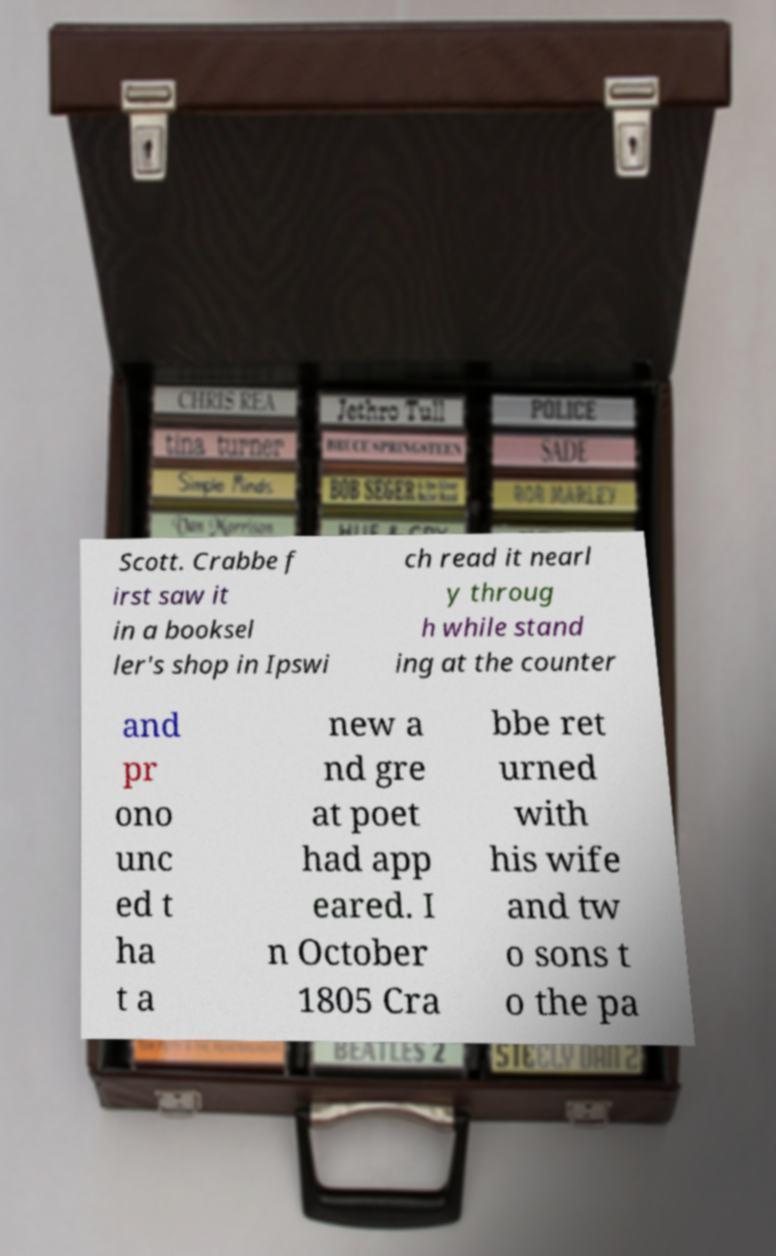For documentation purposes, I need the text within this image transcribed. Could you provide that? Scott. Crabbe f irst saw it in a booksel ler's shop in Ipswi ch read it nearl y throug h while stand ing at the counter and pr ono unc ed t ha t a new a nd gre at poet had app eared. I n October 1805 Cra bbe ret urned with his wife and tw o sons t o the pa 